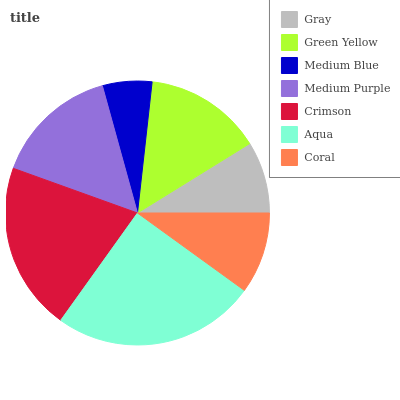Is Medium Blue the minimum?
Answer yes or no. Yes. Is Aqua the maximum?
Answer yes or no. Yes. Is Green Yellow the minimum?
Answer yes or no. No. Is Green Yellow the maximum?
Answer yes or no. No. Is Green Yellow greater than Gray?
Answer yes or no. Yes. Is Gray less than Green Yellow?
Answer yes or no. Yes. Is Gray greater than Green Yellow?
Answer yes or no. No. Is Green Yellow less than Gray?
Answer yes or no. No. Is Green Yellow the high median?
Answer yes or no. Yes. Is Green Yellow the low median?
Answer yes or no. Yes. Is Gray the high median?
Answer yes or no. No. Is Medium Blue the low median?
Answer yes or no. No. 